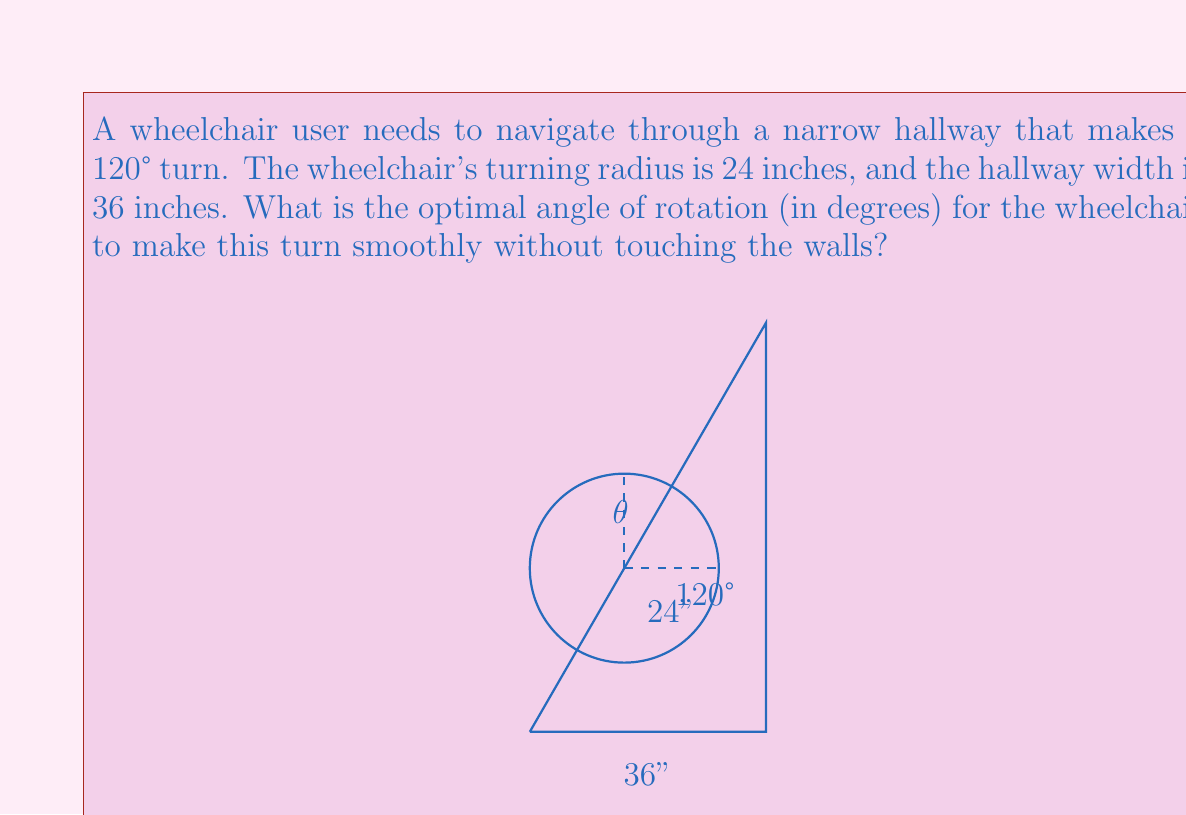Help me with this question. To find the optimal angle of rotation, we'll follow these steps:

1) First, we need to understand that the optimal path for the wheelchair will be tangent to both walls at the corner.

2) The wheelchair's center will trace an arc of a circle with radius 24 inches (the turning radius) during the turn.

3) The hallway forms two sides of an equilateral triangle (due to the 120° turn). The wheelchair's path will form the third side of this triangle.

4) In an equilateral triangle, the radius of the inscribed circle is given by:

   $$r = \frac{a}{2\sqrt{3}}$$

   where $a$ is the side length of the triangle.

5) We know that the hallway width (36 inches) is the difference between the side length of this equilateral triangle and the diameter of the wheelchair's turning circle:

   $$a - 2r = 36$$
   $$a - 2(24) = 36$$
   $$a = 84\text{ inches}$$

6) Now we can find the radius of the inscribed circle:

   $$r = \frac{84}{2\sqrt{3}} = 24.25\text{ inches}$$

7) The angle of rotation $\theta$ is the central angle in the wheelchair's turning circle that corresponds to the arc it traces. This angle is supplementary to the 120° angle of the hallway:

   $$\theta + 120° = 180°$$
   $$\theta = 60°$$

Therefore, the optimal angle of rotation for the wheelchair is 60°.
Answer: 60° 